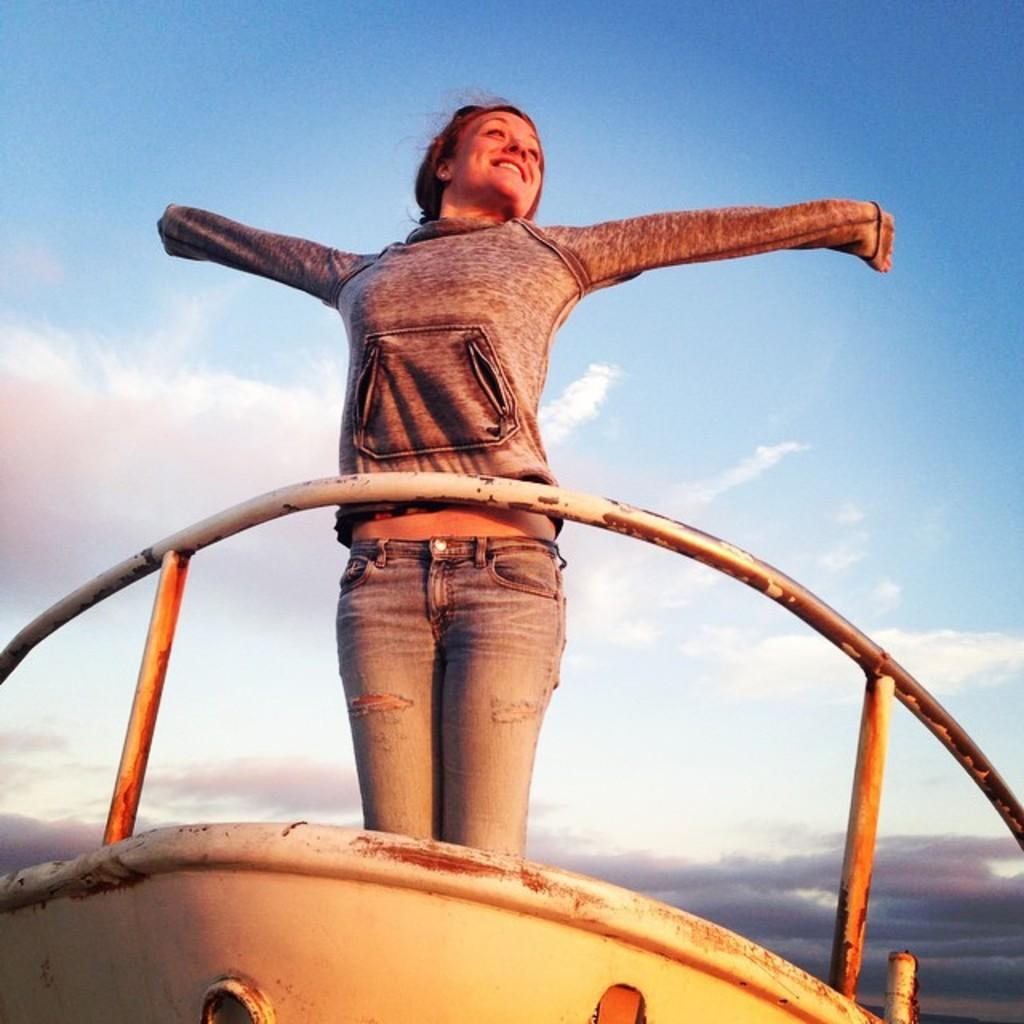What is the main subject of the image? The main subject of the image is a boat. Who or what is in the boat? A woman is standing in the boat. What can be seen in the background of the image? The sky is visible in the background of the image, and clouds are present. How many sisters are sitting on the boat in the image? There are no sisters present in the image; only a woman is standing in the boat. What type of letters can be seen on the boat in the image? There are no letters visible on the boat in the image. 